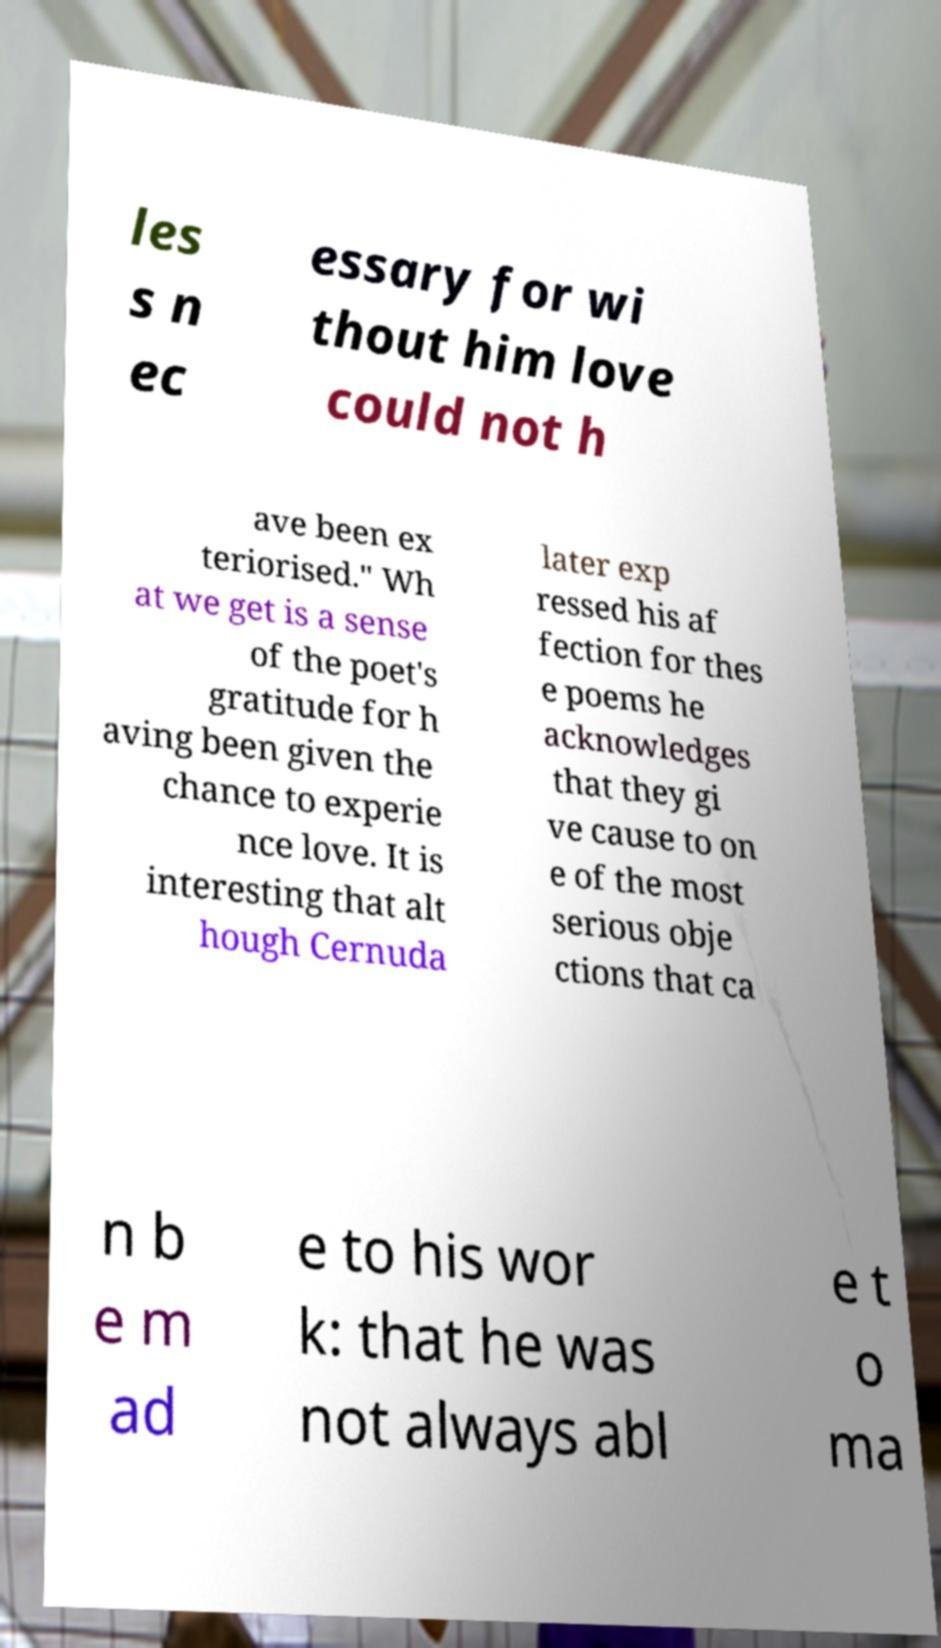What messages or text are displayed in this image? I need them in a readable, typed format. les s n ec essary for wi thout him love could not h ave been ex teriorised." Wh at we get is a sense of the poet's gratitude for h aving been given the chance to experie nce love. It is interesting that alt hough Cernuda later exp ressed his af fection for thes e poems he acknowledges that they gi ve cause to on e of the most serious obje ctions that ca n b e m ad e to his wor k: that he was not always abl e t o ma 